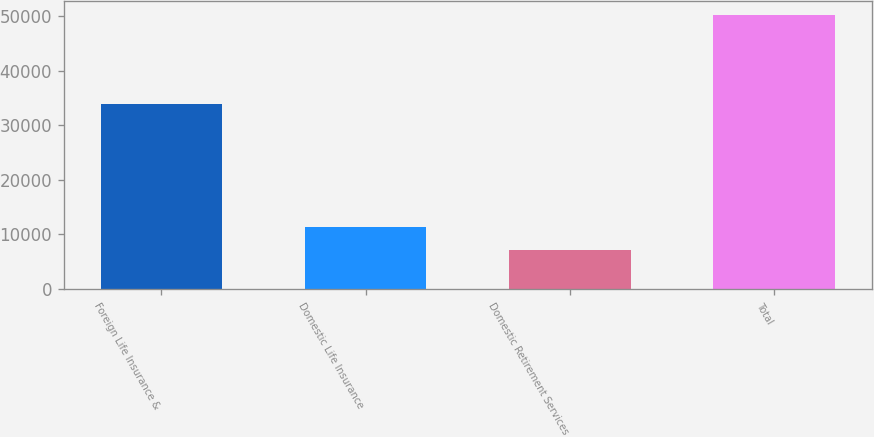Convert chart to OTSL. <chart><loc_0><loc_0><loc_500><loc_500><bar_chart><fcel>Foreign Life Insurance &<fcel>Domestic Life Insurance<fcel>Domestic Retirement Services<fcel>Total<nl><fcel>33916<fcel>11443.2<fcel>7141<fcel>50163<nl></chart> 